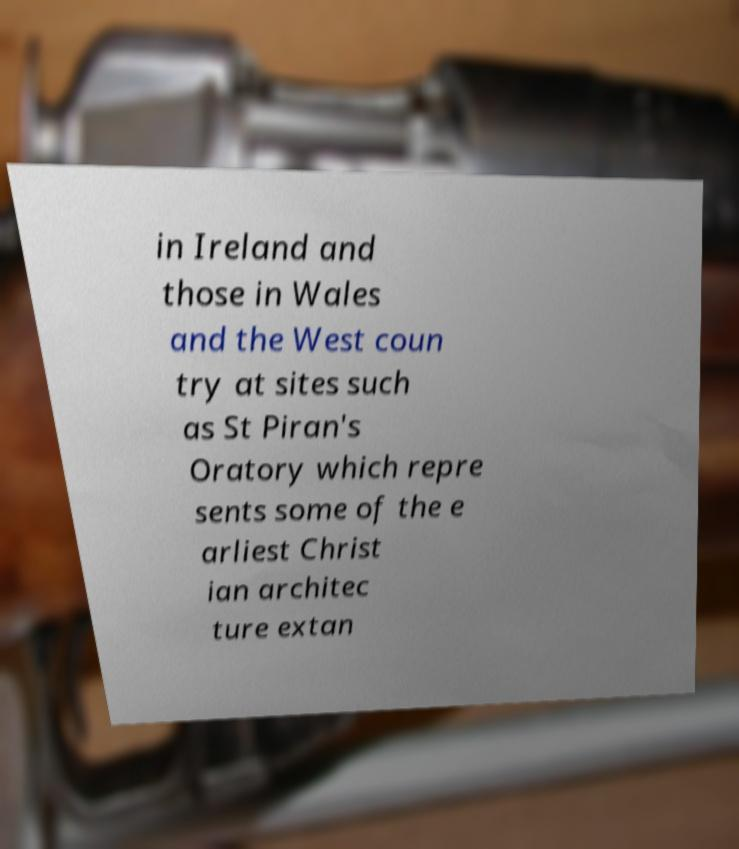Please identify and transcribe the text found in this image. in Ireland and those in Wales and the West coun try at sites such as St Piran's Oratory which repre sents some of the e arliest Christ ian architec ture extan 